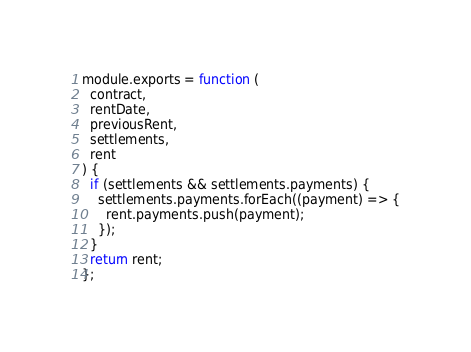Convert code to text. <code><loc_0><loc_0><loc_500><loc_500><_JavaScript_>module.exports = function (
  contract,
  rentDate,
  previousRent,
  settlements,
  rent
) {
  if (settlements && settlements.payments) {
    settlements.payments.forEach((payment) => {
      rent.payments.push(payment);
    });
  }
  return rent;
};
</code> 